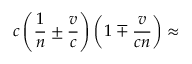Convert formula to latex. <formula><loc_0><loc_0><loc_500><loc_500>c \left ( { \frac { 1 } { n } } \pm { \frac { v } { c } } \right ) \left ( 1 \mp { \frac { v } { c n } } \right ) \approx</formula> 